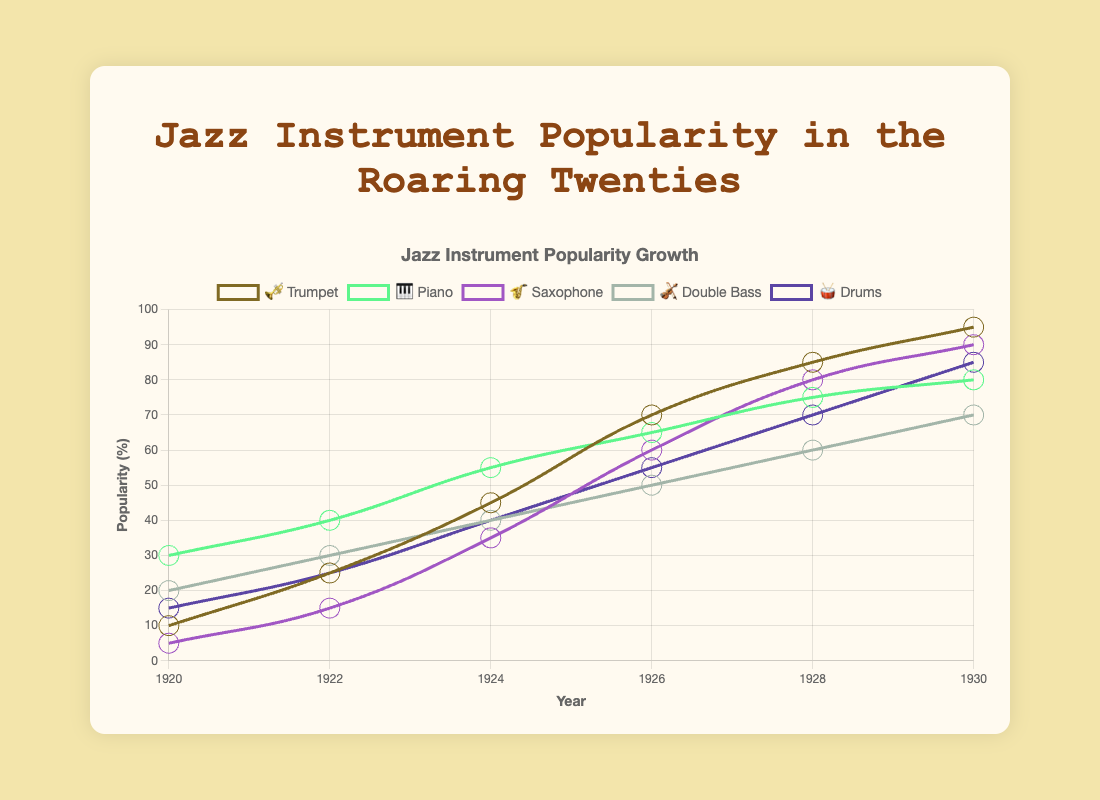What is the title of the chart? The title is displayed at the top of the chart and reads "Jazz Instrument Popularity Growth."
Answer: Jazz Instrument Popularity Growth What is the popularity of the 🎺 Trumpet in 1926? Locate the year 1926 on the x-axis, then find the corresponding value for 🎺 Trumpet on the y-axis, which is 70.
Answer: 70 Which instrument has the highest popularity in 1930? Look at the values for all instruments in 1930, the highest is 🎺 Trumpet with a value of 95.
Answer: 🎺 Trumpet What is the average popularity of 🎷 Saxophone from 1920 to 1930? Add the values for 🎷 Saxophone [5, 15, 35, 60, 80, 90], which results in 285. Divide by 6 (number of years): 285/6 = 47.5.
Answer: 47.5 In 1928, which instrument had a lower popularity: 🎹 Piano or 🎻 Double Bass? In 1928, compare the values: 🎹 Piano has 75 and 🎻 Double Bass has 60. 🎻 Double Bass has lower popularity.
Answer: 🎻 Double Bass Identify the instrument that showed a consistent increase in popularity every recorded year. Examine each instrument's popularity trend over the years. 🎺 Trumpet shows a consistent increase: [10, 25, 45, 70, 85, 95].
Answer: 🎺 Trumpet What is the total popularity percentage for all instruments combined in 1930? Sum the popularity values of all instruments in 1930: 🎺 95 + 🎹 80 + 🎷 90 + 🎻 70 + 🥁 85 = 420.
Answer: 420 Which year saw the greatest increase in 🎹 Piano popularity compared to the previous recorded year? Calculate increases for each period: 
1920-1922: 40-30 = 10,
1922-24: 55-40 = 15,
1924-26: 65-55 = 10,
1926-28: 75-65 = 10,
1928-30: 80-75 = 5.
The greatest increase is 1922-1924.
Answer: 1922-1924 How many instruments reached popularity values above 80 by 1930? Check 1930 values for each instrument: 🎺 95, 🎹 80, 🎷 90, 🎻 70, 🥁 85. Three instruments had values above 80: 🎺, 🎷, and 🥁.
Answer: 3 